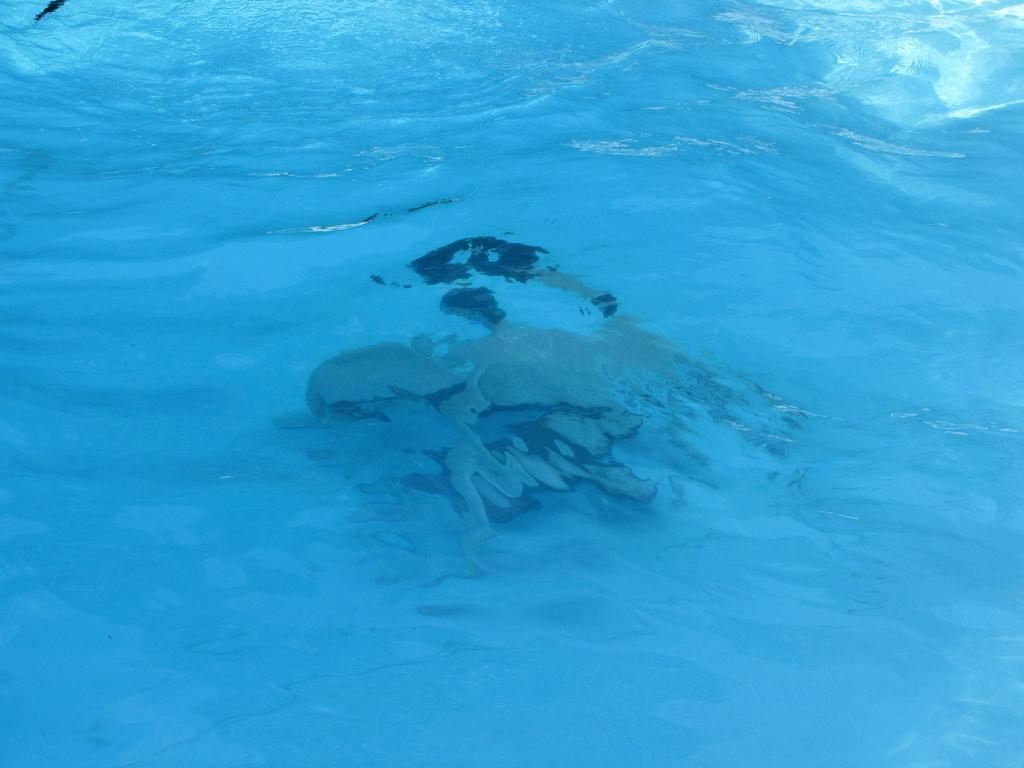How would you summarize this image in a sentence or two? In this image I can see the water. Inside the water, I can see a person swimming. 